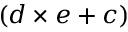Convert formula to latex. <formula><loc_0><loc_0><loc_500><loc_500>( d \times e + c )</formula> 